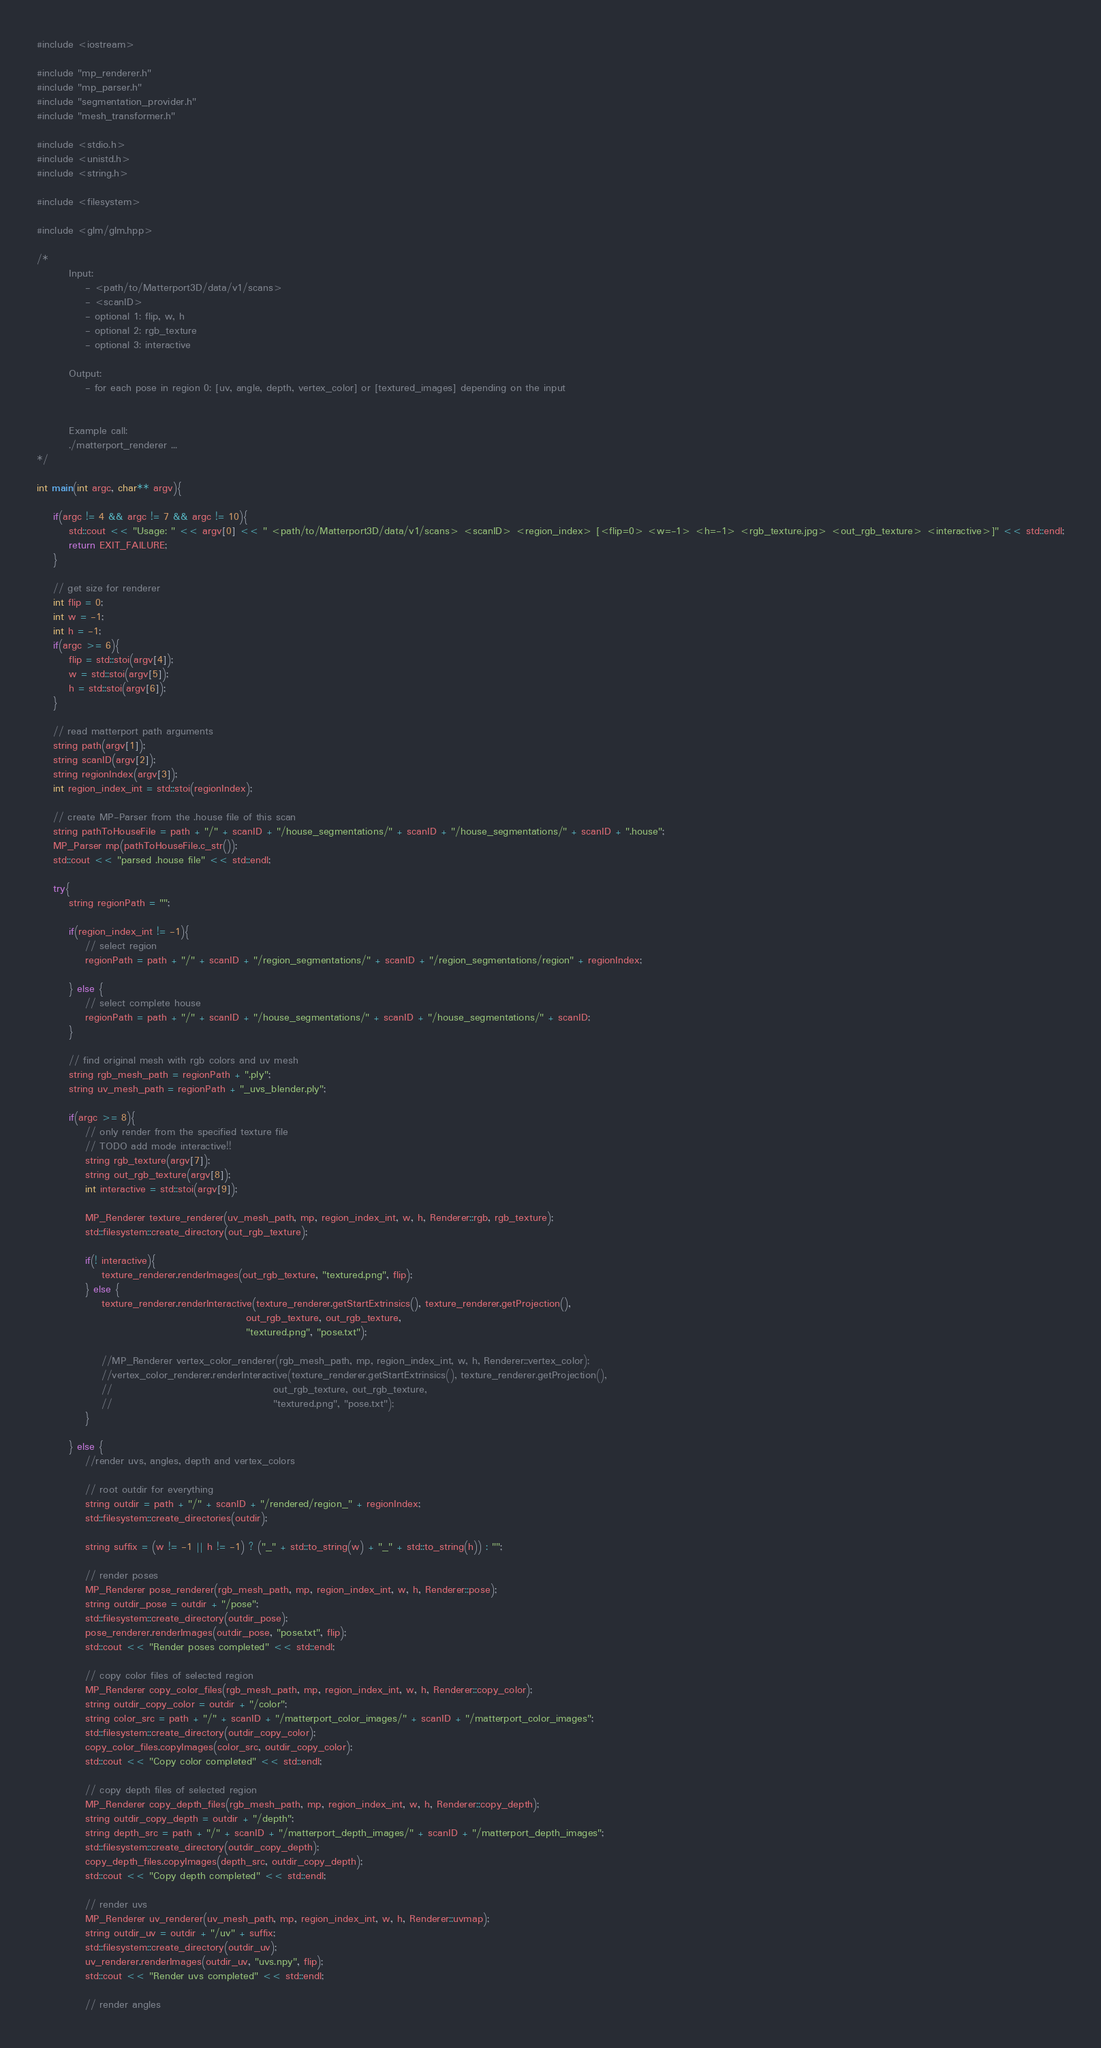Convert code to text. <code><loc_0><loc_0><loc_500><loc_500><_C++_>#include <iostream>

#include "mp_renderer.h"
#include "mp_parser.h"
#include "segmentation_provider.h"
#include "mesh_transformer.h"

#include <stdio.h>
#include <unistd.h>
#include <string.h>

#include <filesystem>

#include <glm/glm.hpp>

/*
        Input:
            - <path/to/Matterport3D/data/v1/scans>
            - <scanID>
            - optional 1: flip, w, h
            - optional 2: rgb_texture
            - optional 3: interactive

        Output:
            - for each pose in region 0: [uv, angle, depth, vertex_color] or [textured_images] depending on the input


        Example call:
        ./matterport_renderer ...
*/

int main(int argc, char** argv){
    
    if(argc != 4 && argc != 7 && argc != 10){
        std::cout << "Usage: " << argv[0] << " <path/to/Matterport3D/data/v1/scans> <scanID> <region_index> [<flip=0> <w=-1> <h=-1> <rgb_texture.jpg> <out_rgb_texture> <interactive>]" << std::endl;
        return EXIT_FAILURE;
    }

    // get size for renderer
    int flip = 0;
    int w = -1;
    int h = -1;
    if(argc >= 6){
        flip = std::stoi(argv[4]);
        w = std::stoi(argv[5]);
        h = std::stoi(argv[6]);
    }

    // read matterport path arguments
    string path(argv[1]);
    string scanID(argv[2]);
    string regionIndex(argv[3]);
    int region_index_int = std::stoi(regionIndex);

    // create MP-Parser from the .house file of this scan
    string pathToHouseFile = path + "/" + scanID + "/house_segmentations/" + scanID + "/house_segmentations/" + scanID + ".house";
    MP_Parser mp(pathToHouseFile.c_str());
    std::cout << "parsed .house file" << std::endl;

    try{
        string regionPath = "";

        if(region_index_int != -1){
            // select region
            regionPath = path + "/" + scanID + "/region_segmentations/" + scanID + "/region_segmentations/region" + regionIndex;

        } else {
            // select complete house
            regionPath = path + "/" + scanID + "/house_segmentations/" + scanID + "/house_segmentations/" + scanID;
        }

        // find original mesh with rgb colors and uv mesh
        string rgb_mesh_path = regionPath + ".ply";
        string uv_mesh_path = regionPath + "_uvs_blender.ply";

        if(argc >= 8){
            // only render from the specified texture file
            // TODO add mode interactive!!
            string rgb_texture(argv[7]);
            string out_rgb_texture(argv[8]);
            int interactive = std::stoi(argv[9]);

            MP_Renderer texture_renderer(uv_mesh_path, mp, region_index_int, w, h, Renderer::rgb, rgb_texture);
            std::filesystem::create_directory(out_rgb_texture);

            if(! interactive){
                texture_renderer.renderImages(out_rgb_texture, "textured.png", flip);
            } else {
                texture_renderer.renderInteractive(texture_renderer.getStartExtrinsics(), texture_renderer.getProjection(),
                                                    out_rgb_texture, out_rgb_texture,
                                                    "textured.png", "pose.txt");
                
                //MP_Renderer vertex_color_renderer(rgb_mesh_path, mp, region_index_int, w, h, Renderer::vertex_color);
                //vertex_color_renderer.renderInteractive(texture_renderer.getStartExtrinsics(), texture_renderer.getProjection(),
                //                                        out_rgb_texture, out_rgb_texture,
                //                                        "textured.png", "pose.txt");
            }
            
        } else {
            //render uvs, angles, depth and vertex_colors

            // root outdir for everything
            string outdir = path + "/" + scanID + "/rendered/region_" + regionIndex;
            std::filesystem::create_directories(outdir);

            string suffix = (w != -1 || h != -1) ? ("_" + std::to_string(w) + "_" + std::to_string(h)) : "";

            // render poses
            MP_Renderer pose_renderer(rgb_mesh_path, mp, region_index_int, w, h, Renderer::pose);
            string outdir_pose = outdir + "/pose";
            std::filesystem::create_directory(outdir_pose);
            pose_renderer.renderImages(outdir_pose, "pose.txt", flip);
            std::cout << "Render poses completed" << std::endl;

            // copy color files of selected region
            MP_Renderer copy_color_files(rgb_mesh_path, mp, region_index_int, w, h, Renderer::copy_color);
            string outdir_copy_color = outdir + "/color";
            string color_src = path + "/" + scanID + "/matterport_color_images/" + scanID + "/matterport_color_images";
            std::filesystem::create_directory(outdir_copy_color);
            copy_color_files.copyImages(color_src, outdir_copy_color);
            std::cout << "Copy color completed" << std::endl;

            // copy depth files of selected region
            MP_Renderer copy_depth_files(rgb_mesh_path, mp, region_index_int, w, h, Renderer::copy_depth);
            string outdir_copy_depth = outdir + "/depth";
            string depth_src = path + "/" + scanID + "/matterport_depth_images/" + scanID + "/matterport_depth_images";
            std::filesystem::create_directory(outdir_copy_depth);
            copy_depth_files.copyImages(depth_src, outdir_copy_depth);
            std::cout << "Copy depth completed" << std::endl;

            // render uvs
            MP_Renderer uv_renderer(uv_mesh_path, mp, region_index_int, w, h, Renderer::uvmap);
            string outdir_uv = outdir + "/uv" + suffix;
            std::filesystem::create_directory(outdir_uv);
            uv_renderer.renderImages(outdir_uv, "uvs.npy", flip);
            std::cout << "Render uvs completed" << std::endl;

            // render angles</code> 